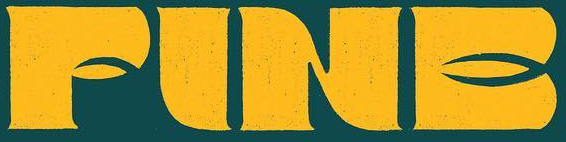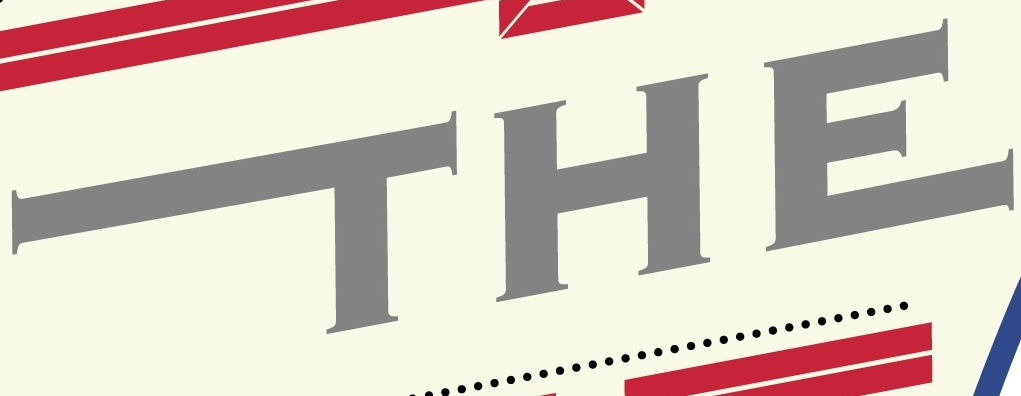What text appears in these images from left to right, separated by a semicolon? FINE; THE 